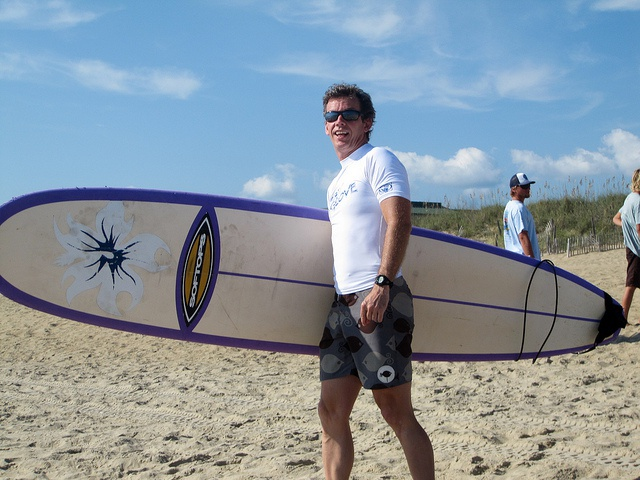Describe the objects in this image and their specific colors. I can see surfboard in lightblue, gray, and navy tones, people in lightblue, black, lavender, maroon, and gray tones, people in lightblue, lavender, gray, and black tones, and people in lightblue, black, darkgray, and lightgray tones in this image. 